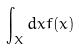Convert formula to latex. <formula><loc_0><loc_0><loc_500><loc_500>\int _ { X } d x f ( x )</formula> 